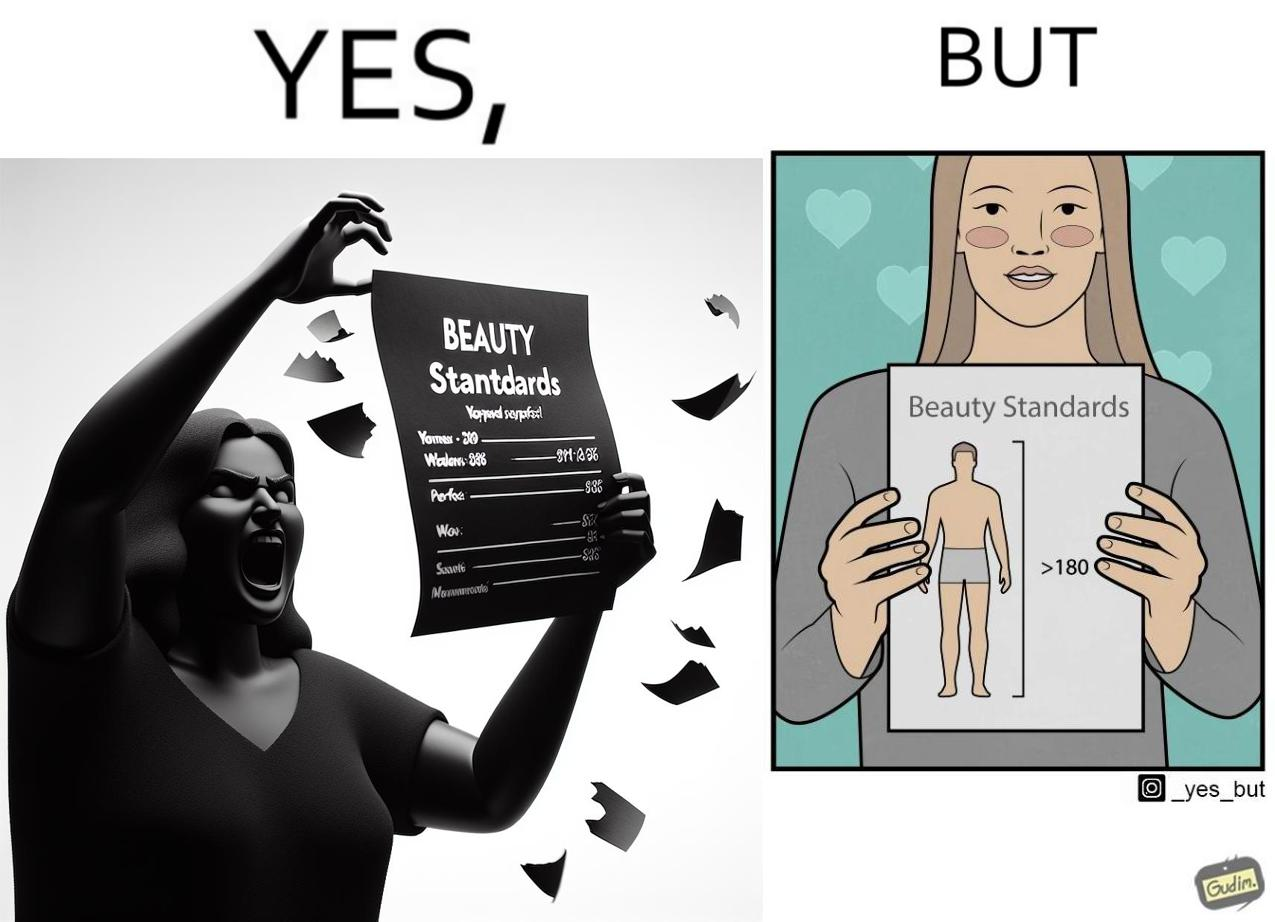Would you classify this image as satirical? Yes, this image is satirical. 